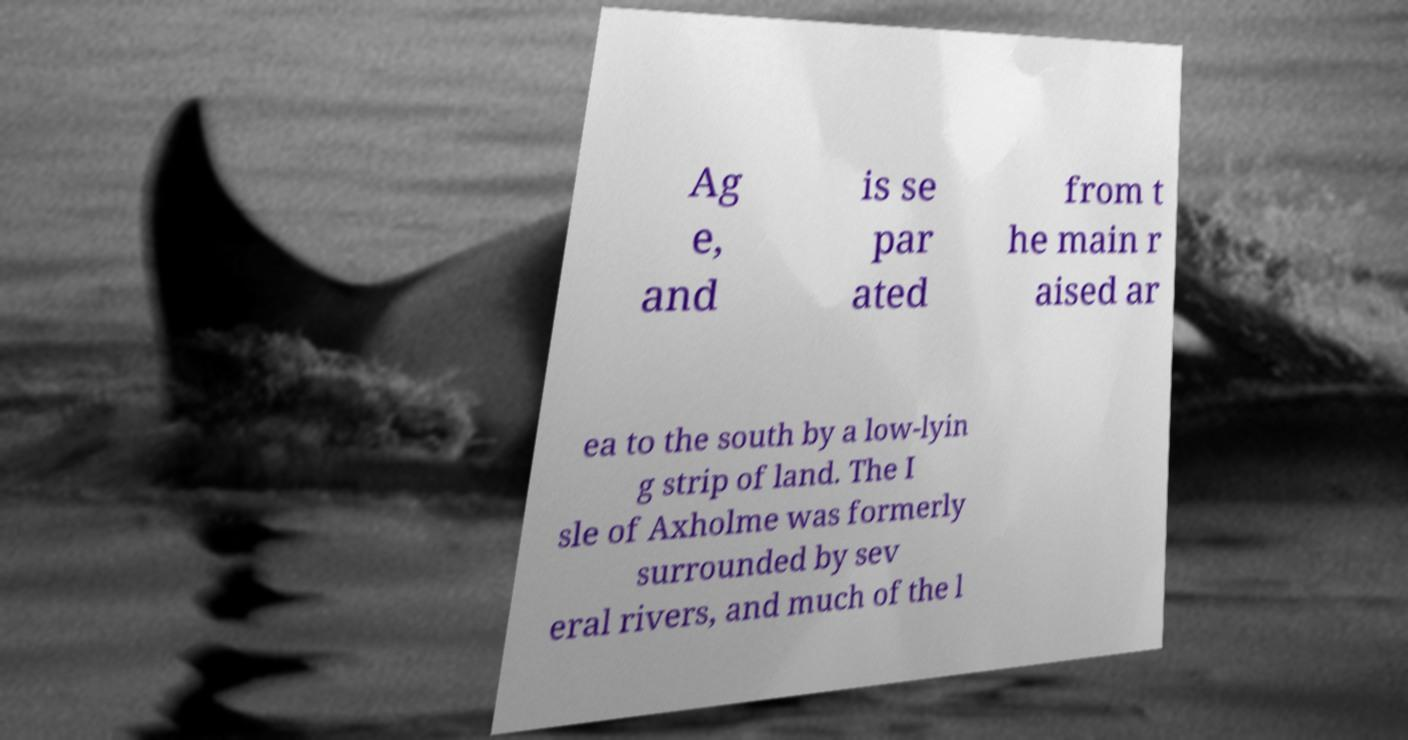For documentation purposes, I need the text within this image transcribed. Could you provide that? Ag e, and is se par ated from t he main r aised ar ea to the south by a low-lyin g strip of land. The I sle of Axholme was formerly surrounded by sev eral rivers, and much of the l 